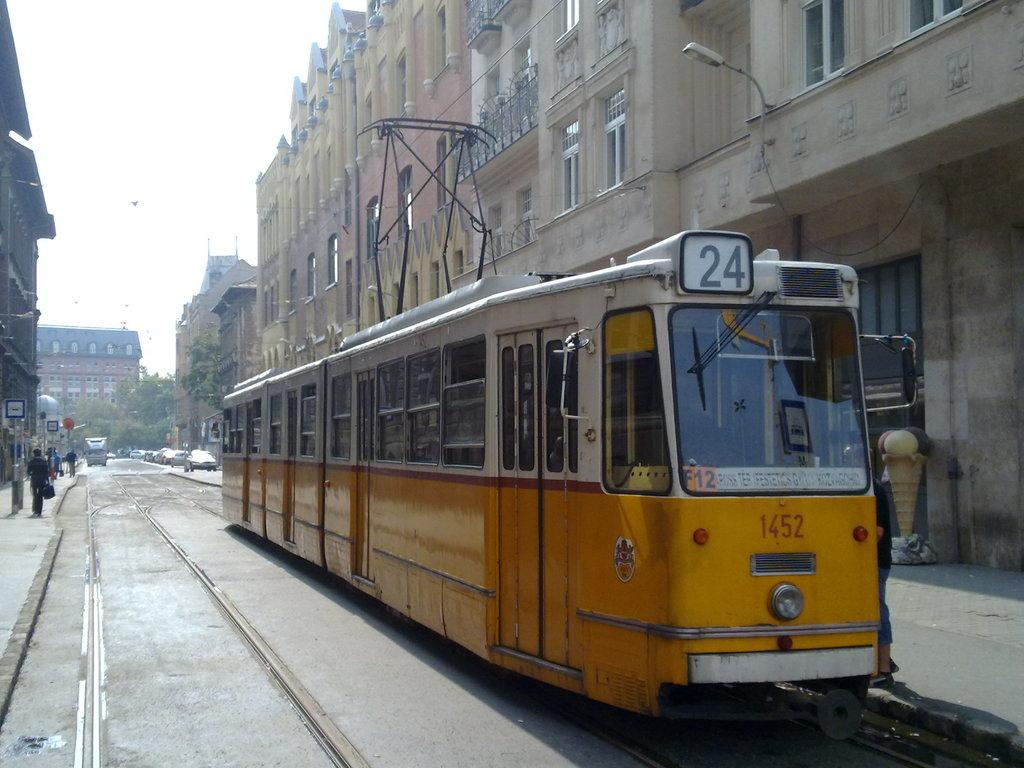<image>
Provide a brief description of the given image. A yellow streetcar with the #24 on the roof and #1452 lower down is seen on a city street. 